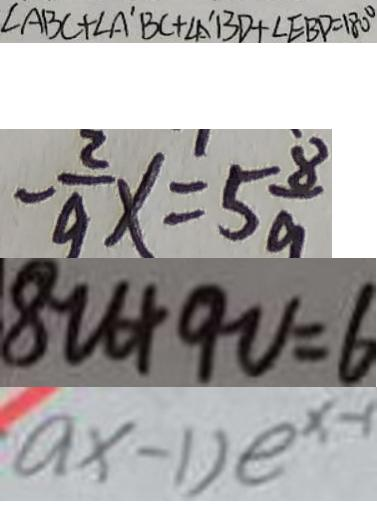Convert formula to latex. <formula><loc_0><loc_0><loc_500><loc_500>\angle A B C + \angle A ^ { \prime } B C + \angle A ^ { \prime } B D + \angle E B D = 1 8 0 ^ { \circ } 
 - \frac { 2 } { 9 } x = 5 \frac { 8 } { 9 } 
 8 u + 9 v = 6 
 a x - 1 ) e ^ { x - 1 }</formula> 